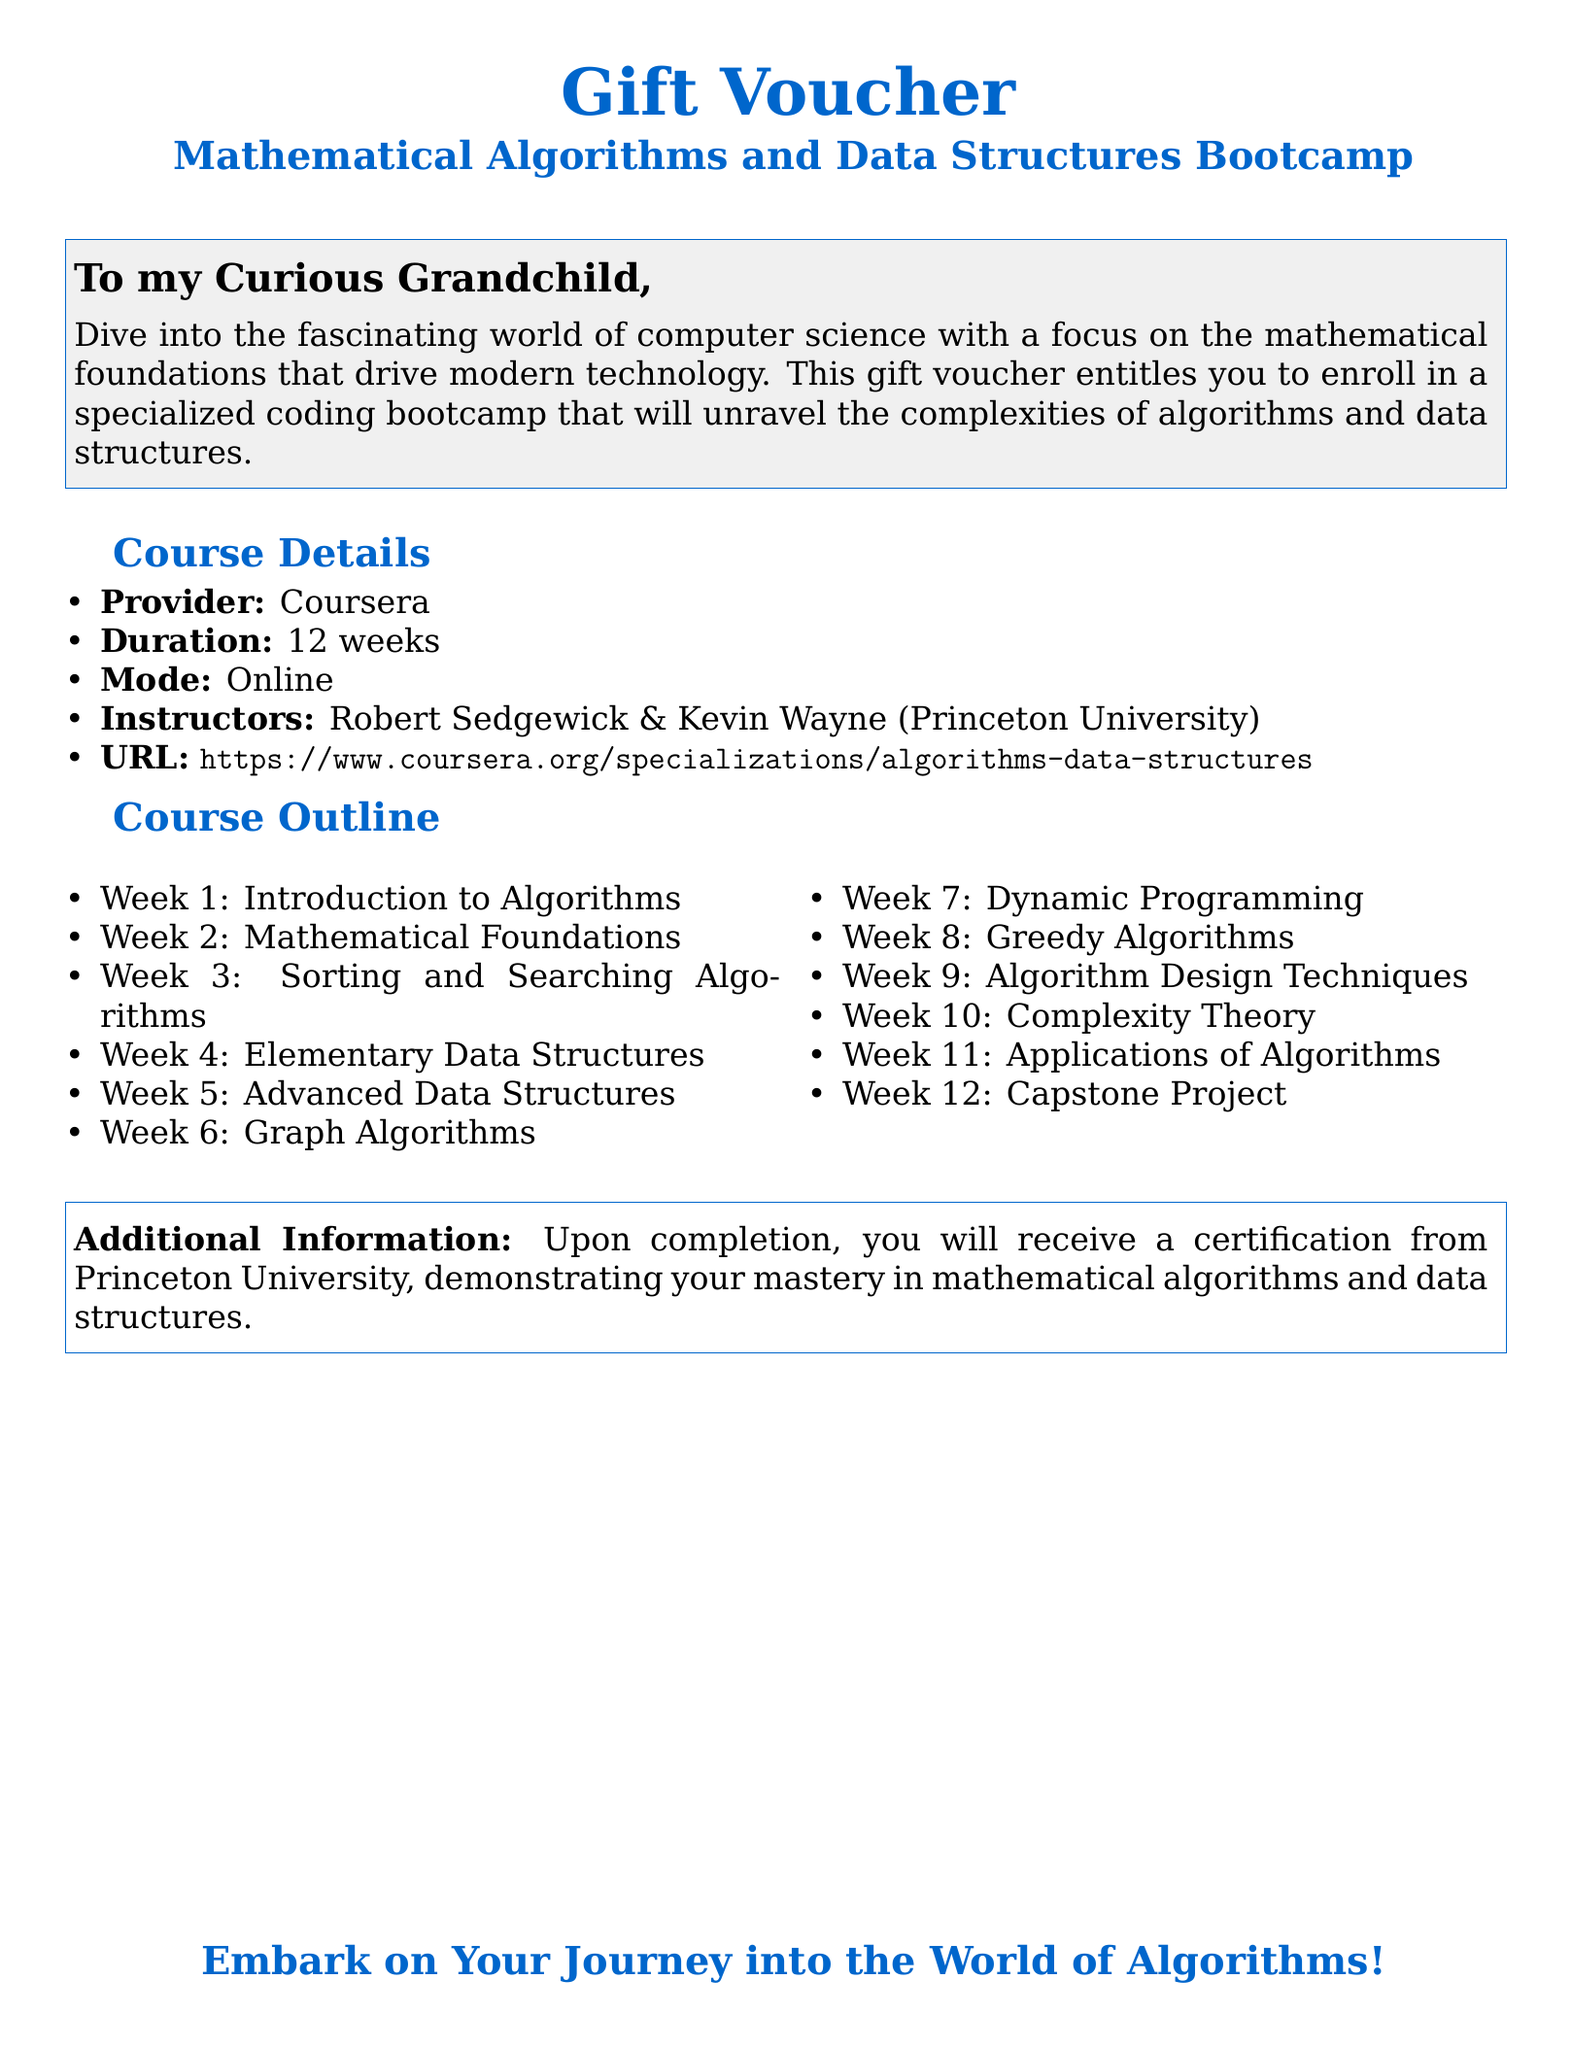What is the title of the course? The title is given as the focus of the voucher, which is "Mathematical Algorithms and Data Structures Bootcamp."
Answer: Mathematical Algorithms and Data Structures Bootcamp How long is the course duration? The duration is specified in the document as 12 weeks.
Answer: 12 weeks Who are the instructors for the bootcamp? The document lists the instructors as Robert Sedgewick and Kevin Wayne.
Answer: Robert Sedgewick & Kevin Wayne What platform offers this course? The provider of the course is mentioned in the document.
Answer: Coursera What will participants receive upon completion of the course? The document states that participants will receive a certification from Princeton University.
Answer: Certification from Princeton University Which week covers Sorting and Searching Algorithms? By reviewing the course outline, Sorting and Searching Algorithms is covered in Week 3.
Answer: Week 3 What is the URL to enroll in the course? The document provides the URL for the course, which is a direct link to Coursera.
Answer: https://www.coursera.org/specializations/algorithms-data-structures How many weeks focus on algorithms in total? The course outline contains specific weeks dedicated to various types of algorithms, totaling 6 weeks.
Answer: 6 weeks What is a unique feature of this gift voucher? The gift voucher's unique aspect is that it entitles the recipient to enroll in a specialized bootcamp.
Answer: Entitles you to enroll in a specialized coding bootcamp 